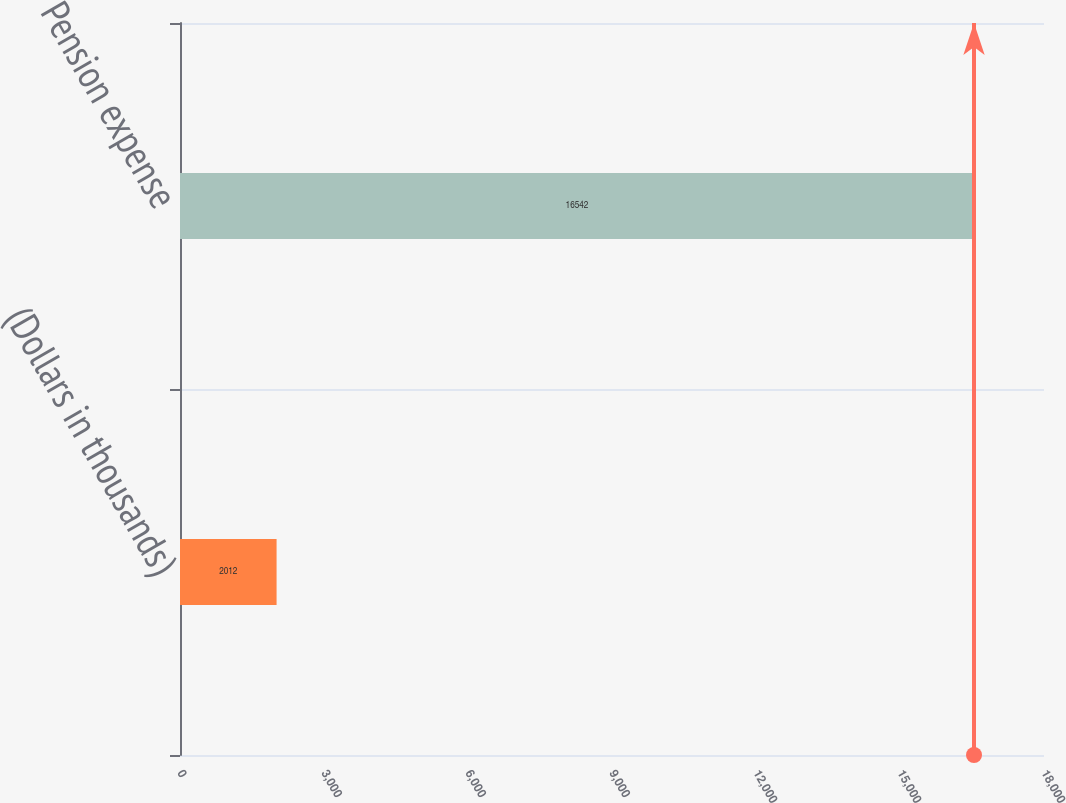<chart> <loc_0><loc_0><loc_500><loc_500><bar_chart><fcel>(Dollars in thousands)<fcel>Pension expense<nl><fcel>2012<fcel>16542<nl></chart> 